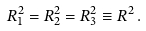<formula> <loc_0><loc_0><loc_500><loc_500>R _ { 1 } ^ { 2 } = R _ { 2 } ^ { 2 } = R _ { 3 } ^ { 2 } \equiv R ^ { 2 } \, .</formula> 